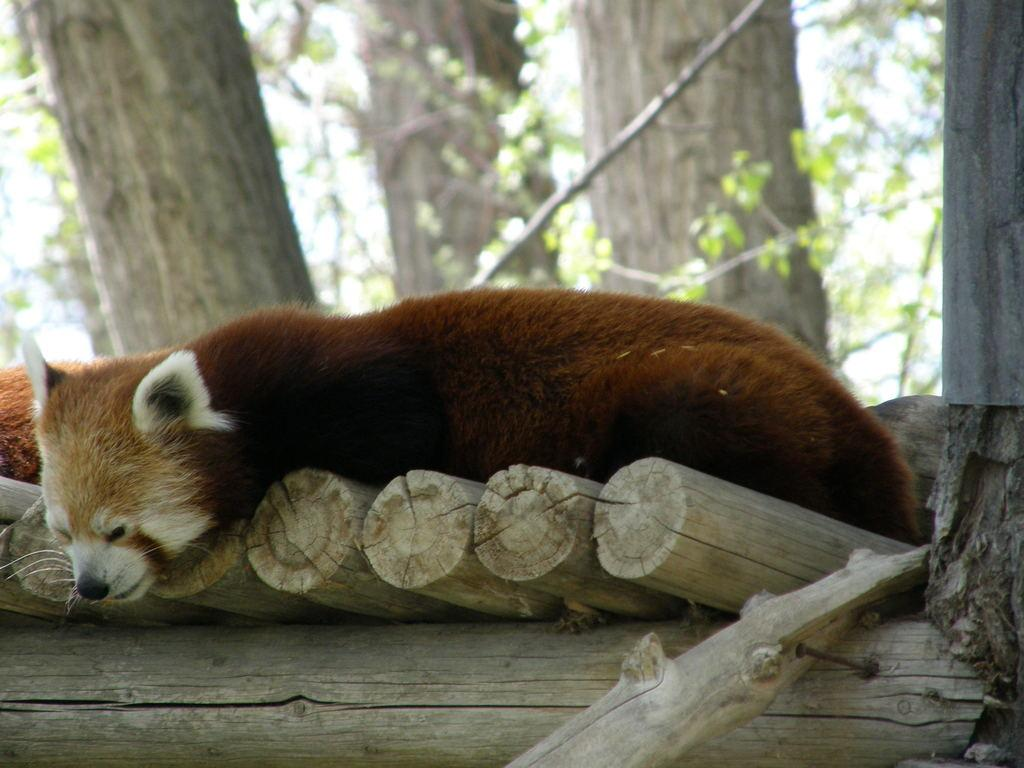What animals are present in the image? There are two red pandas in the image. Where are the red pandas located? The red pandas are resting on a wooden surface. What can be seen in the background of the image? There are trees in the background of the image. How many kittens are resting on the yoke in the image? There are no kittens or yokes present in the image; it features two red pandas resting on a wooden surface. 